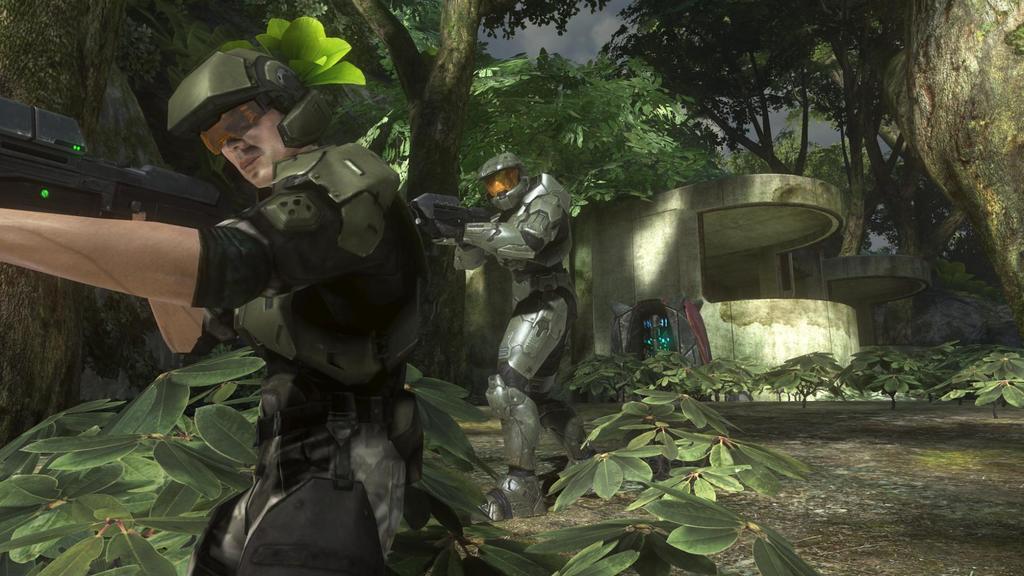Could you give a brief overview of what you see in this image? This is an animated picture. In this picture, we see two men wearing helmets are standing. The man in the middle of the picture is holding the gun in his hand. At the bottom of the picture, we see plants. There are trees and buildings in the background. 